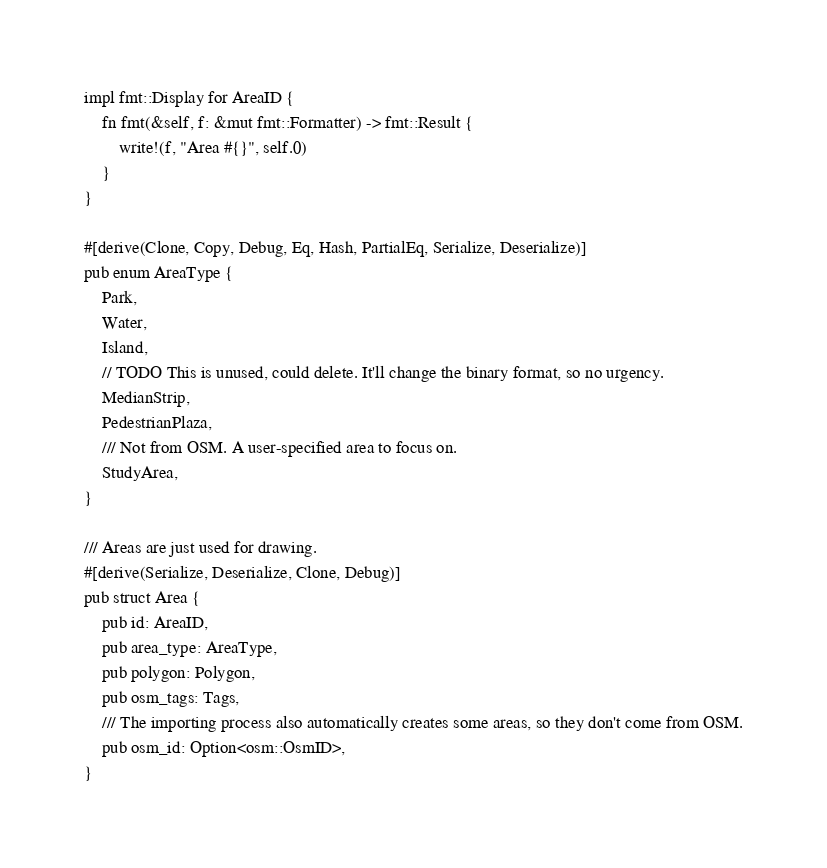Convert code to text. <code><loc_0><loc_0><loc_500><loc_500><_Rust_>impl fmt::Display for AreaID {
    fn fmt(&self, f: &mut fmt::Formatter) -> fmt::Result {
        write!(f, "Area #{}", self.0)
    }
}

#[derive(Clone, Copy, Debug, Eq, Hash, PartialEq, Serialize, Deserialize)]
pub enum AreaType {
    Park,
    Water,
    Island,
    // TODO This is unused, could delete. It'll change the binary format, so no urgency.
    MedianStrip,
    PedestrianPlaza,
    /// Not from OSM. A user-specified area to focus on.
    StudyArea,
}

/// Areas are just used for drawing.
#[derive(Serialize, Deserialize, Clone, Debug)]
pub struct Area {
    pub id: AreaID,
    pub area_type: AreaType,
    pub polygon: Polygon,
    pub osm_tags: Tags,
    /// The importing process also automatically creates some areas, so they don't come from OSM.
    pub osm_id: Option<osm::OsmID>,
}
</code> 